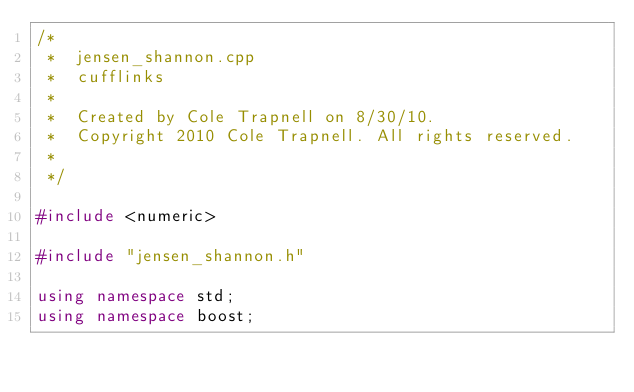Convert code to text. <code><loc_0><loc_0><loc_500><loc_500><_C++_>/*
 *  jensen_shannon.cpp
 *  cufflinks
 *
 *  Created by Cole Trapnell on 8/30/10.
 *  Copyright 2010 Cole Trapnell. All rights reserved.
 *
 */

#include <numeric>

#include "jensen_shannon.h"

using namespace std;
using namespace boost;

</code> 